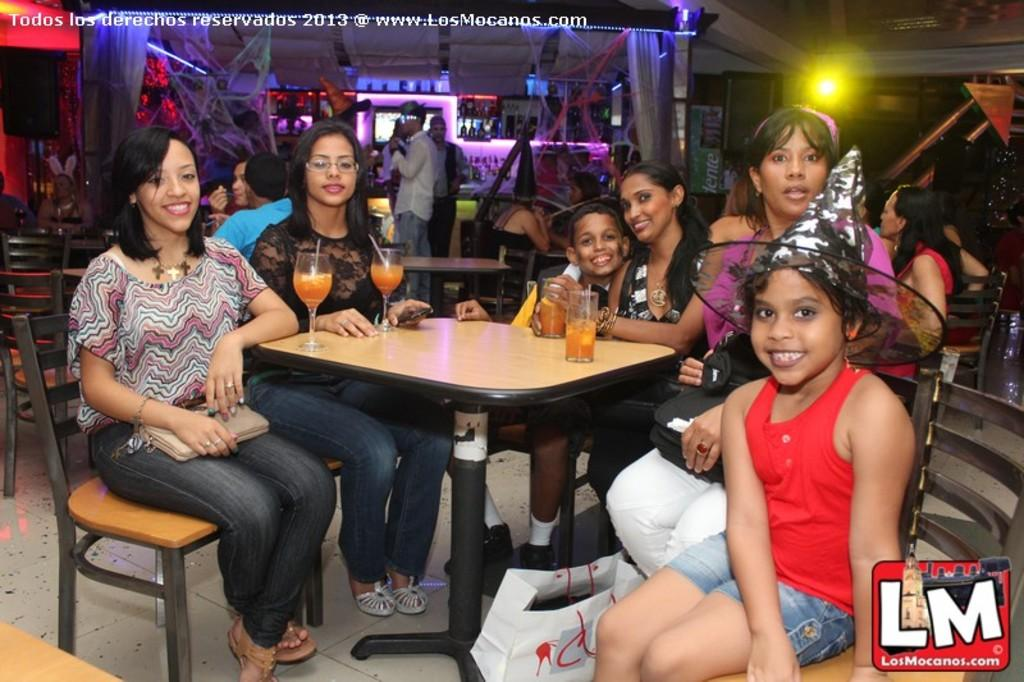What are the people in the image doing? There is a group of people sitting in chairs, and another group of people standing in the background. Can you describe the lighting in the image? There is light in the image. What type of crime is being committed in the image? There is no crime being committed in the image; it simply shows a group of people sitting and standing. Can you tell me how many guitars are present in the image? There are no guitars present in the image. 